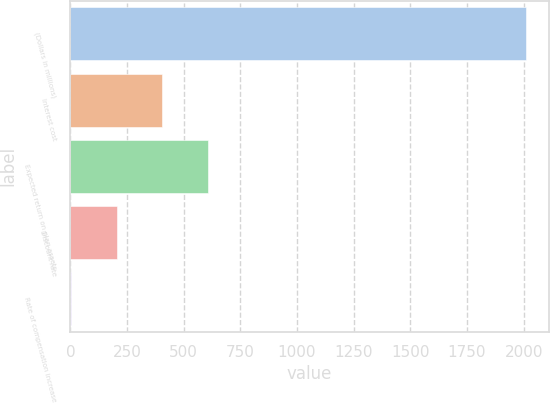Convert chart to OTSL. <chart><loc_0><loc_0><loc_500><loc_500><bar_chart><fcel>(Dollars in millions)<fcel>Interest cost<fcel>Expected return on plan assets<fcel>Discount rate<fcel>Rate of compensation increase<nl><fcel>2010<fcel>405.73<fcel>606.26<fcel>205.2<fcel>4.67<nl></chart> 